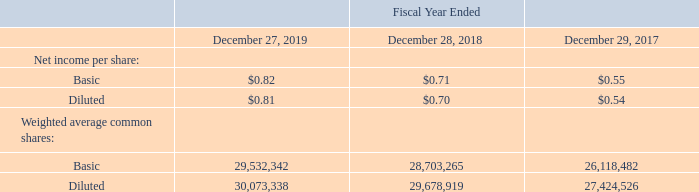Note 3 – Net Income per Share
The following table sets forth the computation of basic and diluted earnings per share:
What is the net income per basic share for fiscal years 2019, 2018 and 2017 respectively? $0.82, $0.71, $0.55. What is the net income per diluted share for fiscal years 2019, 2018 and 2017 respectively? $0.81, $0.70, $0.54. What information does the table set forth? The computation of basic and diluted earnings per share. Which year has the highest net income per basic share? $0.82>$0.71>$0.55
Answer: 2019. What is the average Net income per basic share from 2017-2019? (0.82+ 0.71+ 0.55)/3
Answer: 0.69. What is the change in net income per diluted share between 2018 and 2019? 0.81-0.70
Answer: 0.11. 